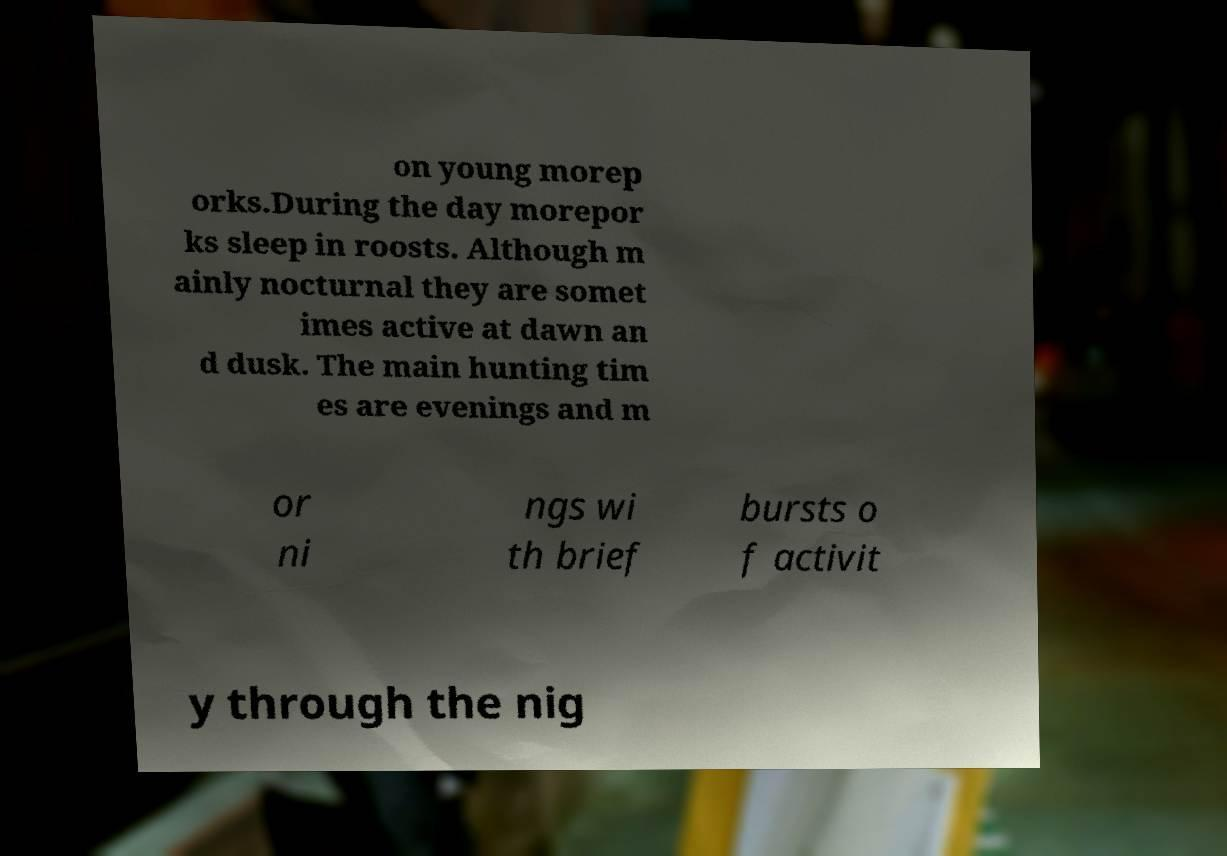For documentation purposes, I need the text within this image transcribed. Could you provide that? on young morep orks.During the day morepor ks sleep in roosts. Although m ainly nocturnal they are somet imes active at dawn an d dusk. The main hunting tim es are evenings and m or ni ngs wi th brief bursts o f activit y through the nig 